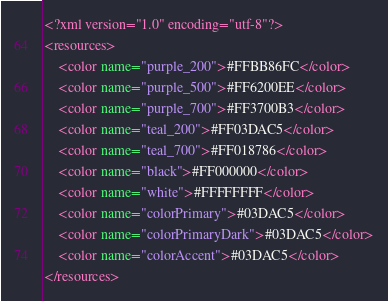<code> <loc_0><loc_0><loc_500><loc_500><_XML_><?xml version="1.0" encoding="utf-8"?>
<resources>
    <color name="purple_200">#FFBB86FC</color>
    <color name="purple_500">#FF6200EE</color>
    <color name="purple_700">#FF3700B3</color>
    <color name="teal_200">#FF03DAC5</color>
    <color name="teal_700">#FF018786</color>
    <color name="black">#FF000000</color>
    <color name="white">#FFFFFFFF</color>
    <color name="colorPrimary">#03DAC5</color>
    <color name="colorPrimaryDark">#03DAC5</color>
    <color name="colorAccent">#03DAC5</color>
</resources></code> 